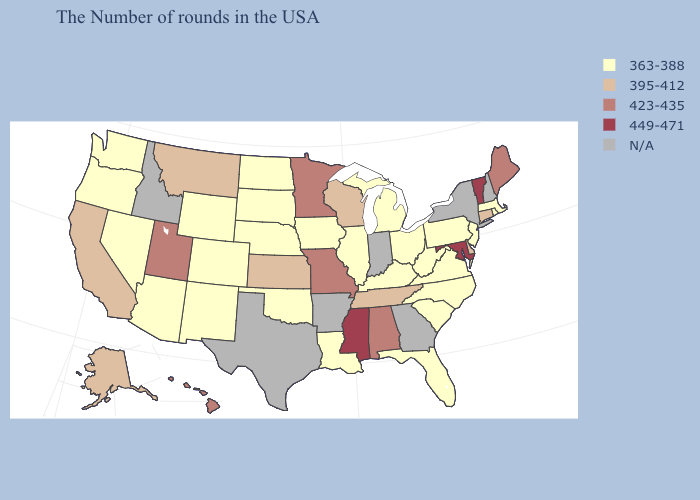What is the highest value in the USA?
Answer briefly. 449-471. Name the states that have a value in the range 363-388?
Be succinct. Massachusetts, Rhode Island, New Jersey, Pennsylvania, Virginia, North Carolina, South Carolina, West Virginia, Ohio, Florida, Michigan, Kentucky, Illinois, Louisiana, Iowa, Nebraska, Oklahoma, South Dakota, North Dakota, Wyoming, Colorado, New Mexico, Arizona, Nevada, Washington, Oregon. What is the highest value in the USA?
Keep it brief. 449-471. Which states have the highest value in the USA?
Quick response, please. Vermont, Maryland, Mississippi. What is the lowest value in the West?
Short answer required. 363-388. How many symbols are there in the legend?
Be succinct. 5. What is the value of South Dakota?
Write a very short answer. 363-388. Does Illinois have the lowest value in the USA?
Answer briefly. Yes. Name the states that have a value in the range 395-412?
Keep it brief. Connecticut, Delaware, Tennessee, Wisconsin, Kansas, Montana, California, Alaska. Does Louisiana have the lowest value in the South?
Short answer required. Yes. Among the states that border North Dakota , which have the lowest value?
Give a very brief answer. South Dakota. Does the map have missing data?
Give a very brief answer. Yes. How many symbols are there in the legend?
Short answer required. 5. Does Utah have the lowest value in the USA?
Answer briefly. No. 